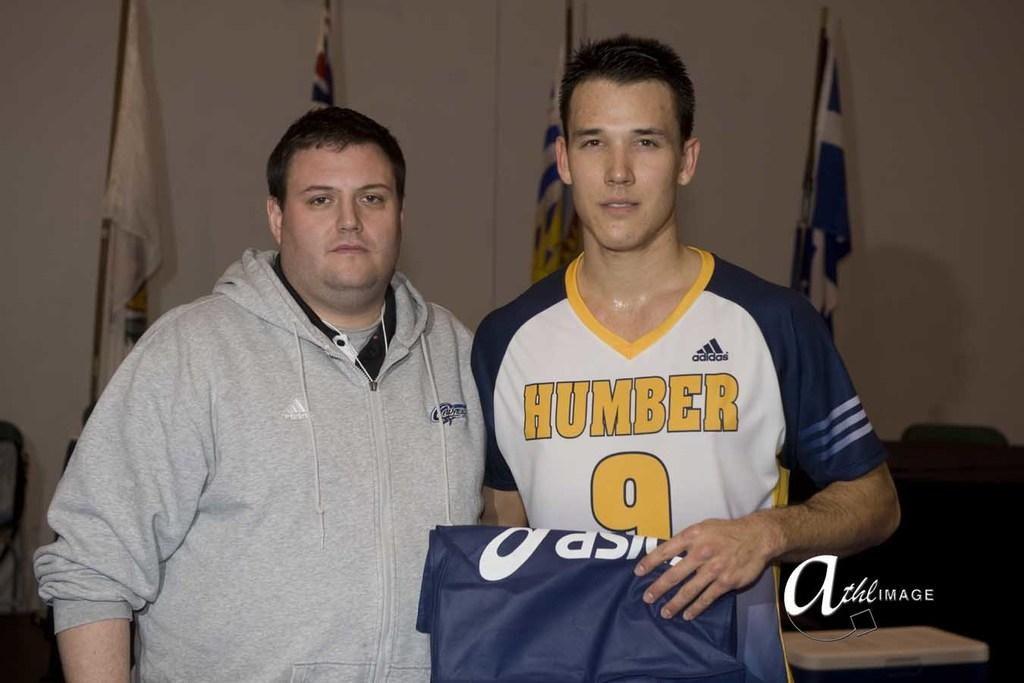<image>
Summarize the visual content of the image. A guy is wearing a jersery with Humber and the number 9 on the front. 